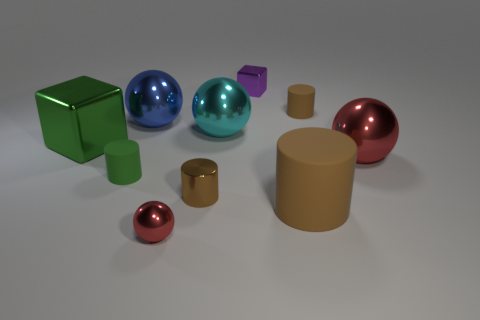Subtract all cyan spheres. How many brown cylinders are left? 3 Subtract all blocks. How many objects are left? 8 Subtract 1 cyan spheres. How many objects are left? 9 Subtract all big yellow rubber objects. Subtract all green rubber cylinders. How many objects are left? 9 Add 3 green cylinders. How many green cylinders are left? 4 Add 2 small green matte spheres. How many small green matte spheres exist? 2 